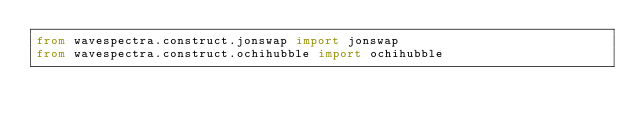Convert code to text. <code><loc_0><loc_0><loc_500><loc_500><_Python_>from wavespectra.construct.jonswap import jonswap
from wavespectra.construct.ochihubble import ochihubble
</code> 